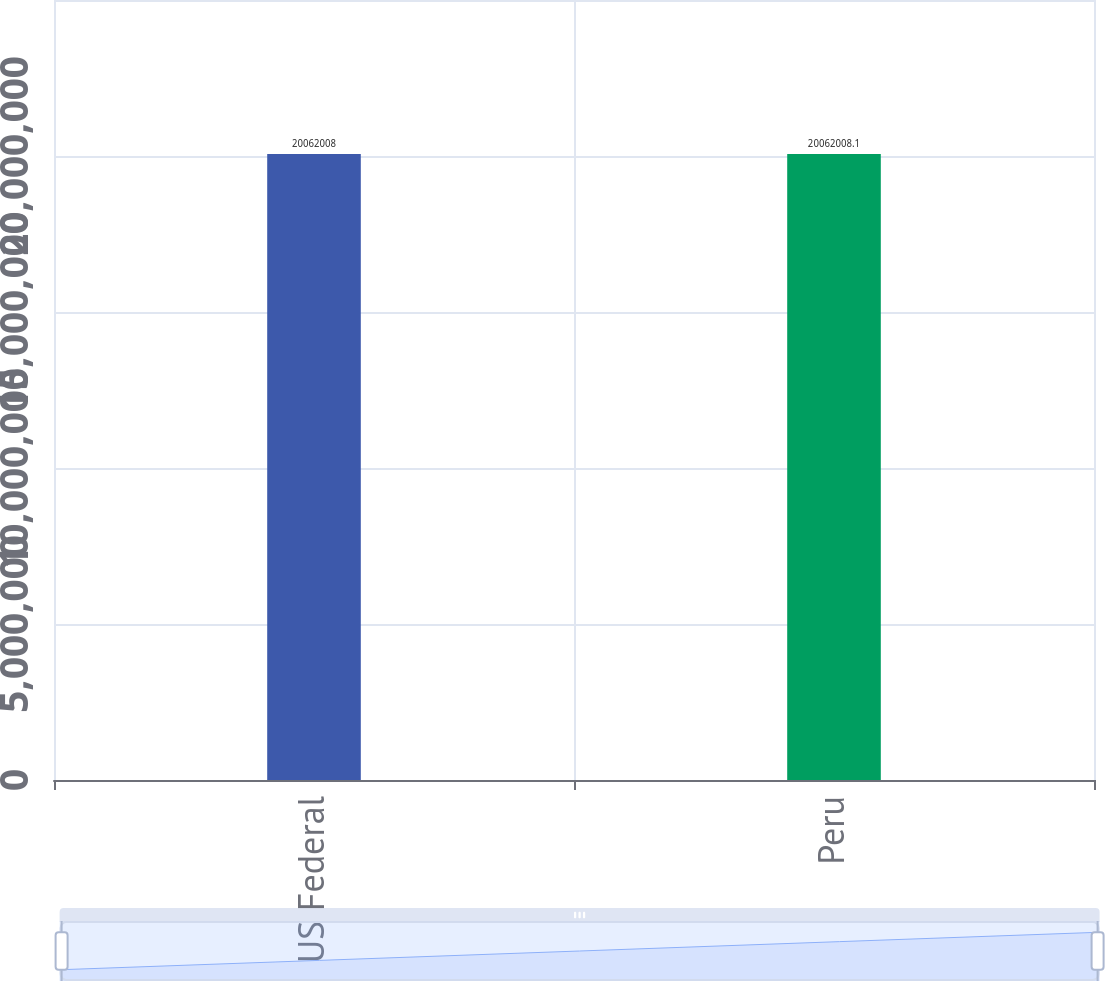Convert chart. <chart><loc_0><loc_0><loc_500><loc_500><bar_chart><fcel>US Federal<fcel>Peru<nl><fcel>2.0062e+07<fcel>2.0062e+07<nl></chart> 